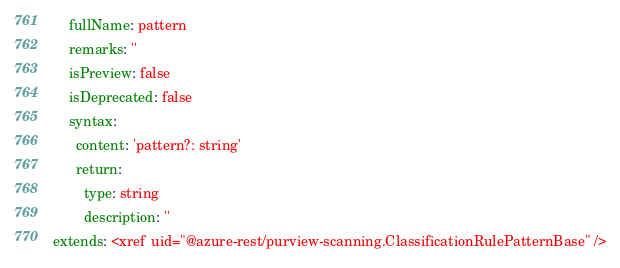Convert code to text. <code><loc_0><loc_0><loc_500><loc_500><_YAML_>    fullName: pattern
    remarks: ''
    isPreview: false
    isDeprecated: false
    syntax:
      content: 'pattern?: string'
      return:
        type: string
        description: ''
extends: <xref uid="@azure-rest/purview-scanning.ClassificationRulePatternBase" />
</code> 